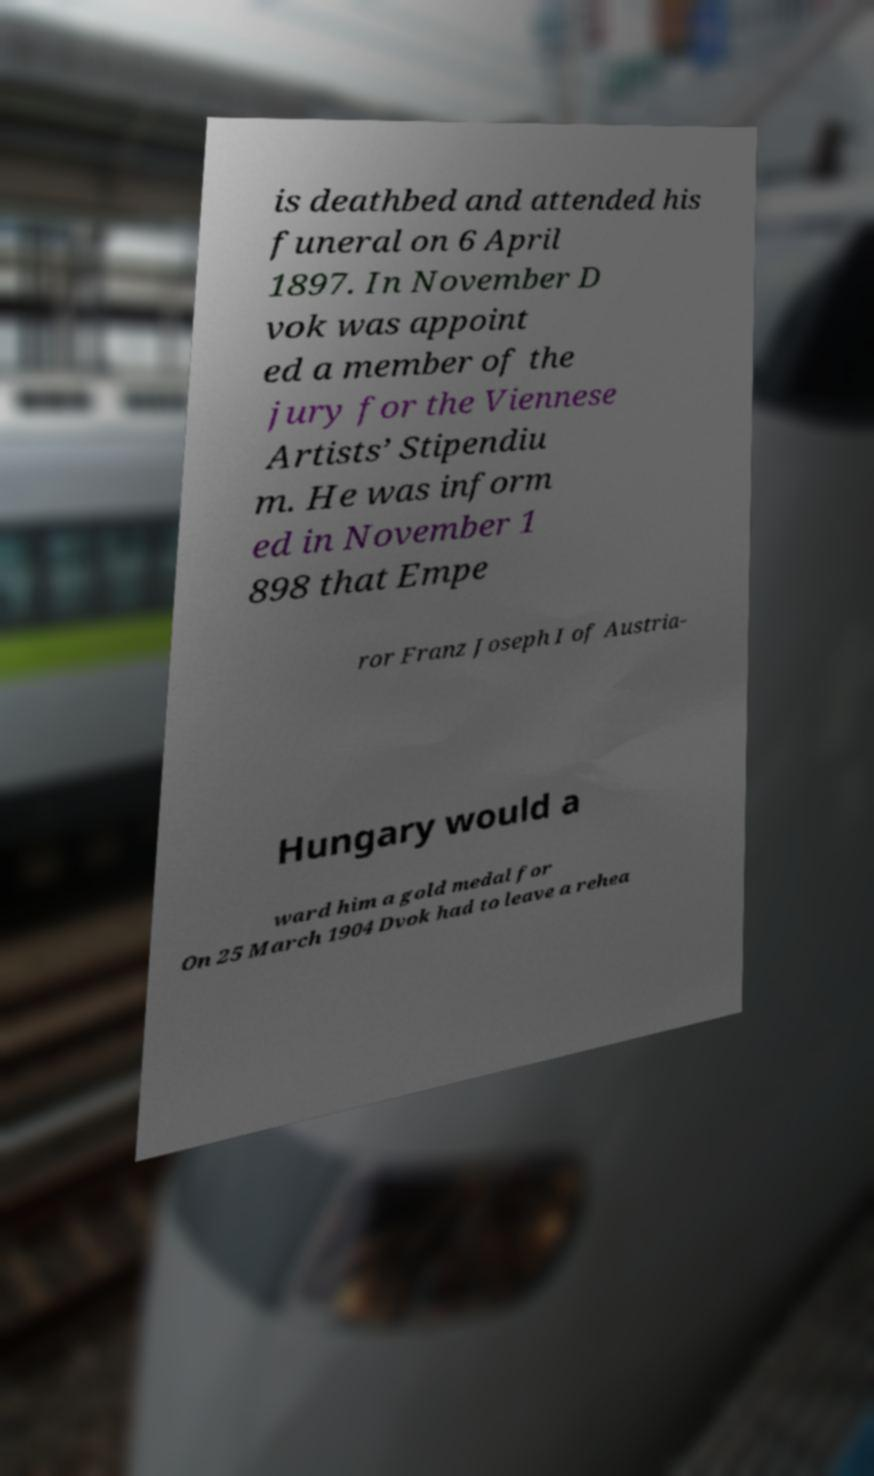What messages or text are displayed in this image? I need them in a readable, typed format. is deathbed and attended his funeral on 6 April 1897. In November D vok was appoint ed a member of the jury for the Viennese Artists’ Stipendiu m. He was inform ed in November 1 898 that Empe ror Franz Joseph I of Austria- Hungary would a ward him a gold medal for On 25 March 1904 Dvok had to leave a rehea 